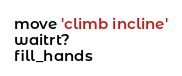Convert code to text. <code><loc_0><loc_0><loc_500><loc_500><_Ruby_>move 'climb incline'
waitrt?
fill_hands</code> 